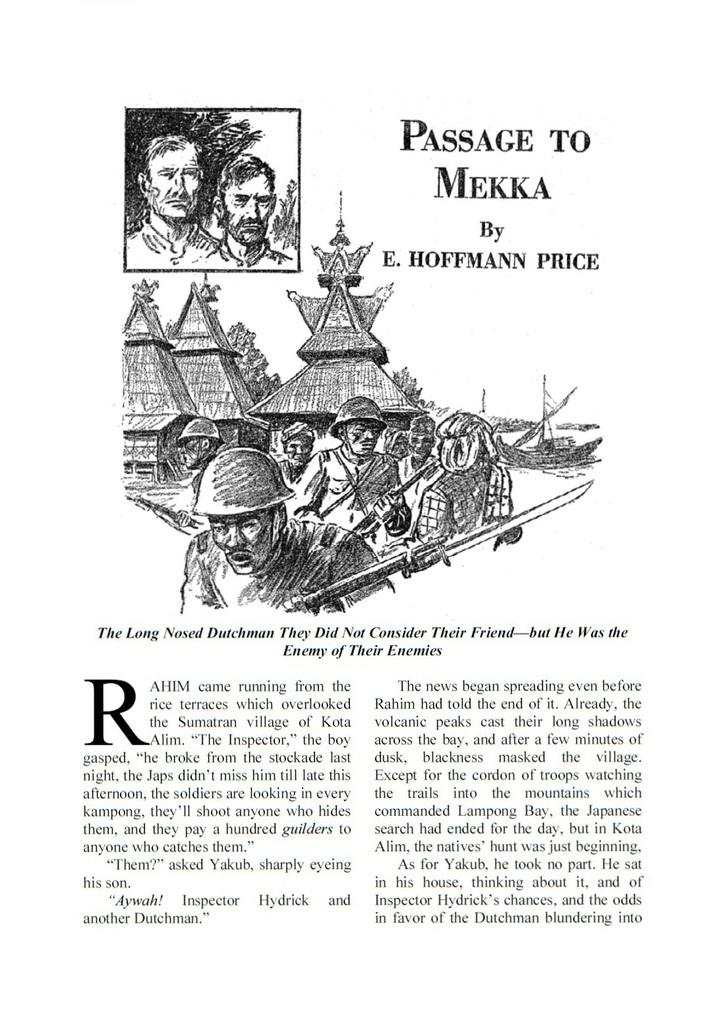What type of paper is present in the image? There is a magazine paper in the image. What is depicted on the magazine paper? The magazine paper contains a drawing sketch of military men. What phrase is written on the top of the magazine paper? The phrase "Passage to Mecca" is written on the top of the magazine paper. How many balls are present in the image? There are no balls present in the image; it features a magazine paper with a drawing sketch of military men and the phrase "Passage to Mecca." 